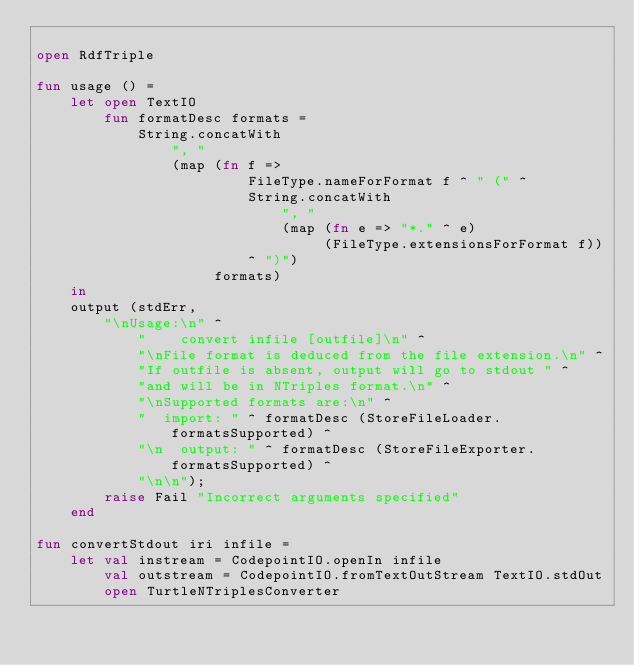Convert code to text. <code><loc_0><loc_0><loc_500><loc_500><_SML_>
open RdfTriple
         
fun usage () =
    let open TextIO
        fun formatDesc formats =
            String.concatWith
                ", "
                (map (fn f =>
                         FileType.nameForFormat f ^ " (" ^
                         String.concatWith
                             ", "
                             (map (fn e => "*." ^ e)
                                  (FileType.extensionsForFormat f))
                         ^ ")")
                     formats)
    in
	output (stdErr,
	    "\nUsage:\n" ^
            "    convert infile [outfile]\n" ^
            "\nFile format is deduced from the file extension.\n" ^
            "If outfile is absent, output will go to stdout " ^
            "and will be in NTriples format.\n" ^
            "\nSupported formats are:\n" ^
            "  import: " ^ formatDesc (StoreFileLoader.formatsSupported) ^
            "\n  output: " ^ formatDesc (StoreFileExporter.formatsSupported) ^
            "\n\n");
        raise Fail "Incorrect arguments specified"
    end

fun convertStdout iri infile =
    let val instream = CodepointIO.openIn infile
        val outstream = CodepointIO.fromTextOutStream TextIO.stdOut
        open TurtleNTriplesConverter</code> 